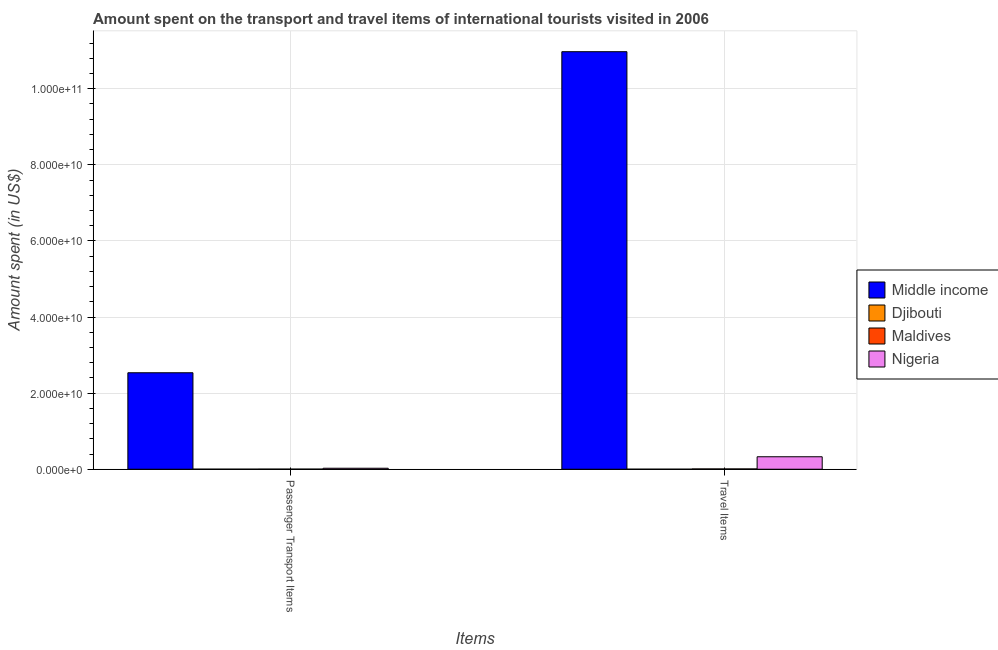How many different coloured bars are there?
Offer a very short reply. 4. How many groups of bars are there?
Provide a succinct answer. 2. What is the label of the 2nd group of bars from the left?
Make the answer very short. Travel Items. What is the amount spent in travel items in Middle income?
Give a very brief answer. 1.10e+11. Across all countries, what is the maximum amount spent in travel items?
Your answer should be very brief. 1.10e+11. Across all countries, what is the minimum amount spent in travel items?
Provide a succinct answer. 3.50e+06. In which country was the amount spent in travel items minimum?
Your answer should be very brief. Djibouti. What is the total amount spent in travel items in the graph?
Ensure brevity in your answer.  1.13e+11. What is the difference between the amount spent in travel items in Djibouti and that in Nigeria?
Ensure brevity in your answer.  -3.28e+09. What is the difference between the amount spent on passenger transport items in Nigeria and the amount spent in travel items in Djibouti?
Your answer should be very brief. 2.54e+08. What is the average amount spent on passenger transport items per country?
Your response must be concise. 6.41e+09. What is the ratio of the amount spent on passenger transport items in Middle income to that in Maldives?
Give a very brief answer. 905.58. What does the 4th bar from the left in Travel Items represents?
Make the answer very short. Nigeria. What does the 3rd bar from the right in Passenger Transport Items represents?
Offer a terse response. Djibouti. What is the difference between two consecutive major ticks on the Y-axis?
Provide a succinct answer. 2.00e+1. Does the graph contain any zero values?
Offer a terse response. No. Does the graph contain grids?
Provide a succinct answer. Yes. What is the title of the graph?
Offer a terse response. Amount spent on the transport and travel items of international tourists visited in 2006. Does "Equatorial Guinea" appear as one of the legend labels in the graph?
Give a very brief answer. No. What is the label or title of the X-axis?
Ensure brevity in your answer.  Items. What is the label or title of the Y-axis?
Your answer should be very brief. Amount spent (in US$). What is the Amount spent (in US$) in Middle income in Passenger Transport Items?
Offer a very short reply. 2.54e+1. What is the Amount spent (in US$) of Djibouti in Passenger Transport Items?
Make the answer very short. 1.15e+07. What is the Amount spent (in US$) of Maldives in Passenger Transport Items?
Offer a very short reply. 2.80e+07. What is the Amount spent (in US$) of Nigeria in Passenger Transport Items?
Ensure brevity in your answer.  2.57e+08. What is the Amount spent (in US$) of Middle income in Travel Items?
Provide a succinct answer. 1.10e+11. What is the Amount spent (in US$) in Djibouti in Travel Items?
Make the answer very short. 3.50e+06. What is the Amount spent (in US$) in Maldives in Travel Items?
Make the answer very short. 7.80e+07. What is the Amount spent (in US$) of Nigeria in Travel Items?
Your answer should be very brief. 3.28e+09. Across all Items, what is the maximum Amount spent (in US$) in Middle income?
Offer a terse response. 1.10e+11. Across all Items, what is the maximum Amount spent (in US$) of Djibouti?
Give a very brief answer. 1.15e+07. Across all Items, what is the maximum Amount spent (in US$) of Maldives?
Your answer should be compact. 7.80e+07. Across all Items, what is the maximum Amount spent (in US$) in Nigeria?
Offer a very short reply. 3.28e+09. Across all Items, what is the minimum Amount spent (in US$) in Middle income?
Ensure brevity in your answer.  2.54e+1. Across all Items, what is the minimum Amount spent (in US$) in Djibouti?
Your answer should be compact. 3.50e+06. Across all Items, what is the minimum Amount spent (in US$) in Maldives?
Your answer should be compact. 2.80e+07. Across all Items, what is the minimum Amount spent (in US$) of Nigeria?
Your response must be concise. 2.57e+08. What is the total Amount spent (in US$) of Middle income in the graph?
Offer a very short reply. 1.35e+11. What is the total Amount spent (in US$) in Djibouti in the graph?
Your answer should be compact. 1.50e+07. What is the total Amount spent (in US$) of Maldives in the graph?
Keep it short and to the point. 1.06e+08. What is the total Amount spent (in US$) of Nigeria in the graph?
Keep it short and to the point. 3.54e+09. What is the difference between the Amount spent (in US$) in Middle income in Passenger Transport Items and that in Travel Items?
Your answer should be very brief. -8.44e+1. What is the difference between the Amount spent (in US$) in Djibouti in Passenger Transport Items and that in Travel Items?
Make the answer very short. 8.00e+06. What is the difference between the Amount spent (in US$) of Maldives in Passenger Transport Items and that in Travel Items?
Provide a succinct answer. -5.00e+07. What is the difference between the Amount spent (in US$) of Nigeria in Passenger Transport Items and that in Travel Items?
Provide a succinct answer. -3.02e+09. What is the difference between the Amount spent (in US$) in Middle income in Passenger Transport Items and the Amount spent (in US$) in Djibouti in Travel Items?
Provide a short and direct response. 2.54e+1. What is the difference between the Amount spent (in US$) in Middle income in Passenger Transport Items and the Amount spent (in US$) in Maldives in Travel Items?
Your answer should be compact. 2.53e+1. What is the difference between the Amount spent (in US$) in Middle income in Passenger Transport Items and the Amount spent (in US$) in Nigeria in Travel Items?
Keep it short and to the point. 2.21e+1. What is the difference between the Amount spent (in US$) of Djibouti in Passenger Transport Items and the Amount spent (in US$) of Maldives in Travel Items?
Your answer should be very brief. -6.65e+07. What is the difference between the Amount spent (in US$) in Djibouti in Passenger Transport Items and the Amount spent (in US$) in Nigeria in Travel Items?
Keep it short and to the point. -3.27e+09. What is the difference between the Amount spent (in US$) of Maldives in Passenger Transport Items and the Amount spent (in US$) of Nigeria in Travel Items?
Give a very brief answer. -3.25e+09. What is the average Amount spent (in US$) of Middle income per Items?
Make the answer very short. 6.75e+1. What is the average Amount spent (in US$) in Djibouti per Items?
Your answer should be compact. 7.50e+06. What is the average Amount spent (in US$) in Maldives per Items?
Provide a short and direct response. 5.30e+07. What is the average Amount spent (in US$) of Nigeria per Items?
Your response must be concise. 1.77e+09. What is the difference between the Amount spent (in US$) of Middle income and Amount spent (in US$) of Djibouti in Passenger Transport Items?
Make the answer very short. 2.53e+1. What is the difference between the Amount spent (in US$) of Middle income and Amount spent (in US$) of Maldives in Passenger Transport Items?
Your answer should be compact. 2.53e+1. What is the difference between the Amount spent (in US$) of Middle income and Amount spent (in US$) of Nigeria in Passenger Transport Items?
Offer a very short reply. 2.51e+1. What is the difference between the Amount spent (in US$) of Djibouti and Amount spent (in US$) of Maldives in Passenger Transport Items?
Offer a very short reply. -1.65e+07. What is the difference between the Amount spent (in US$) in Djibouti and Amount spent (in US$) in Nigeria in Passenger Transport Items?
Provide a succinct answer. -2.46e+08. What is the difference between the Amount spent (in US$) in Maldives and Amount spent (in US$) in Nigeria in Passenger Transport Items?
Provide a short and direct response. -2.29e+08. What is the difference between the Amount spent (in US$) in Middle income and Amount spent (in US$) in Djibouti in Travel Items?
Make the answer very short. 1.10e+11. What is the difference between the Amount spent (in US$) of Middle income and Amount spent (in US$) of Maldives in Travel Items?
Your answer should be very brief. 1.10e+11. What is the difference between the Amount spent (in US$) in Middle income and Amount spent (in US$) in Nigeria in Travel Items?
Keep it short and to the point. 1.06e+11. What is the difference between the Amount spent (in US$) of Djibouti and Amount spent (in US$) of Maldives in Travel Items?
Provide a succinct answer. -7.45e+07. What is the difference between the Amount spent (in US$) in Djibouti and Amount spent (in US$) in Nigeria in Travel Items?
Provide a succinct answer. -3.28e+09. What is the difference between the Amount spent (in US$) of Maldives and Amount spent (in US$) of Nigeria in Travel Items?
Provide a succinct answer. -3.20e+09. What is the ratio of the Amount spent (in US$) of Middle income in Passenger Transport Items to that in Travel Items?
Ensure brevity in your answer.  0.23. What is the ratio of the Amount spent (in US$) in Djibouti in Passenger Transport Items to that in Travel Items?
Ensure brevity in your answer.  3.29. What is the ratio of the Amount spent (in US$) of Maldives in Passenger Transport Items to that in Travel Items?
Your response must be concise. 0.36. What is the ratio of the Amount spent (in US$) in Nigeria in Passenger Transport Items to that in Travel Items?
Give a very brief answer. 0.08. What is the difference between the highest and the second highest Amount spent (in US$) in Middle income?
Make the answer very short. 8.44e+1. What is the difference between the highest and the second highest Amount spent (in US$) in Djibouti?
Make the answer very short. 8.00e+06. What is the difference between the highest and the second highest Amount spent (in US$) in Maldives?
Give a very brief answer. 5.00e+07. What is the difference between the highest and the second highest Amount spent (in US$) of Nigeria?
Give a very brief answer. 3.02e+09. What is the difference between the highest and the lowest Amount spent (in US$) of Middle income?
Your answer should be compact. 8.44e+1. What is the difference between the highest and the lowest Amount spent (in US$) of Djibouti?
Keep it short and to the point. 8.00e+06. What is the difference between the highest and the lowest Amount spent (in US$) of Maldives?
Offer a terse response. 5.00e+07. What is the difference between the highest and the lowest Amount spent (in US$) in Nigeria?
Your answer should be very brief. 3.02e+09. 